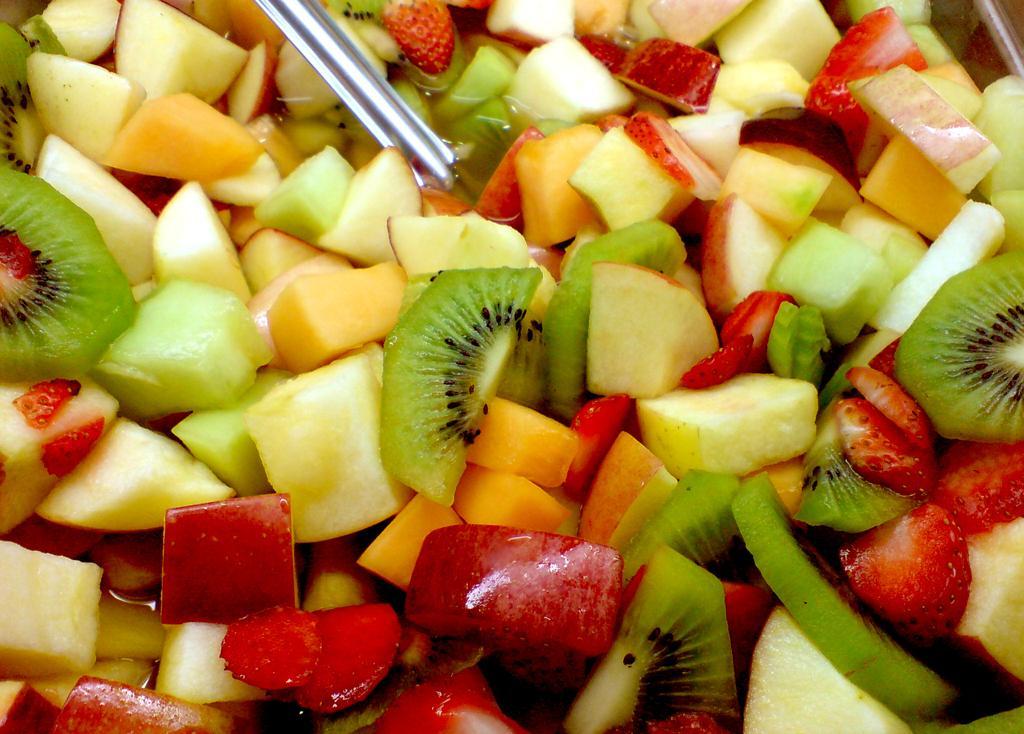Could you give a brief overview of what you see in this image? In this image there are chopped fruits, liquid and a spoon.   